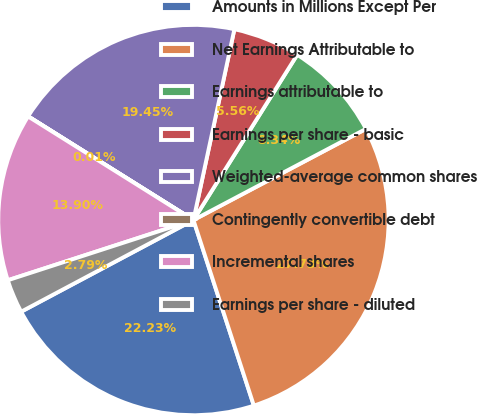<chart> <loc_0><loc_0><loc_500><loc_500><pie_chart><fcel>Amounts in Millions Except Per<fcel>Net Earnings Attributable to<fcel>Earnings attributable to<fcel>Earnings per share - basic<fcel>Weighted-average common shares<fcel>Contingently convertible debt<fcel>Incremental shares<fcel>Earnings per share - diluted<nl><fcel>22.23%<fcel>27.73%<fcel>8.34%<fcel>5.56%<fcel>19.45%<fcel>0.01%<fcel>13.9%<fcel>2.79%<nl></chart> 